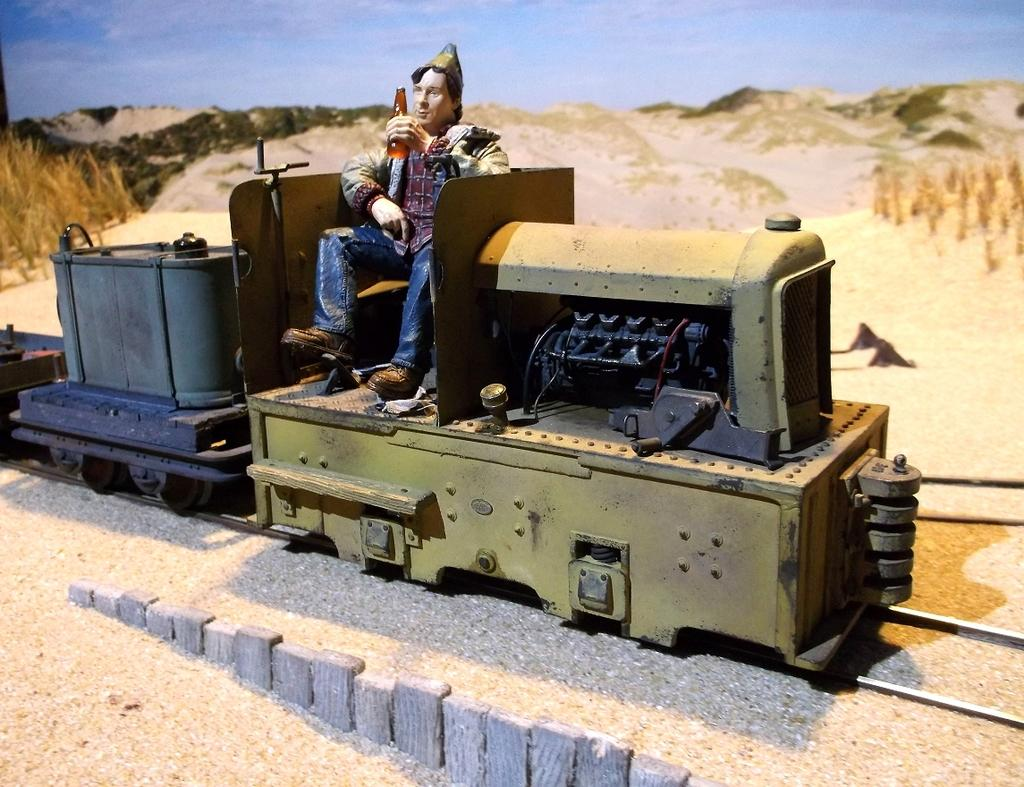What is the main subject of the image? The main subject of the image is a toy man. What is the toy man sitting on? The toy man is sitting on a toy train. What is the toy train positioned on? The toy train is on a railway track. What can be seen in the background of the image? Hills and the sky are visible in the background of the image. What type of fear does the toy man express in the image? The image does not depict any emotions or expressions of fear from the toy man. How does the toy man contribute to the society in the image? The image does not show the toy man interacting with or affecting any society. 